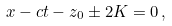Convert formula to latex. <formula><loc_0><loc_0><loc_500><loc_500>x - c t - z _ { 0 } \pm 2 K = 0 \, ,</formula> 